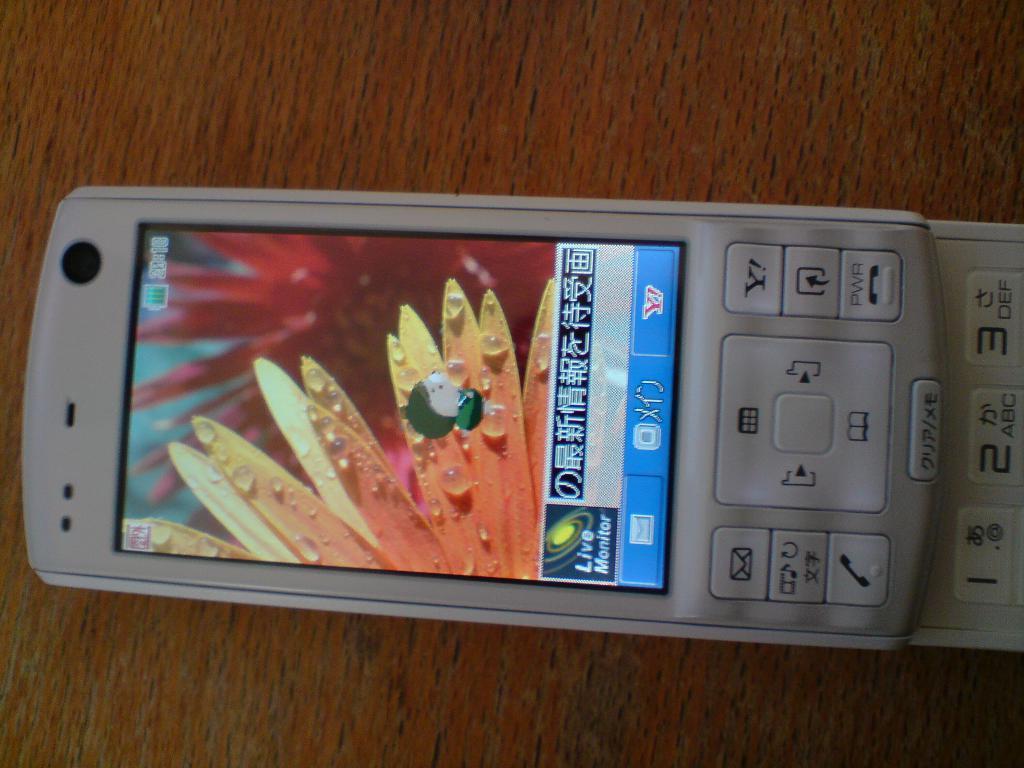Please provide a concise description of this image. In this picture I can see the mobile phone on the wooden table. 